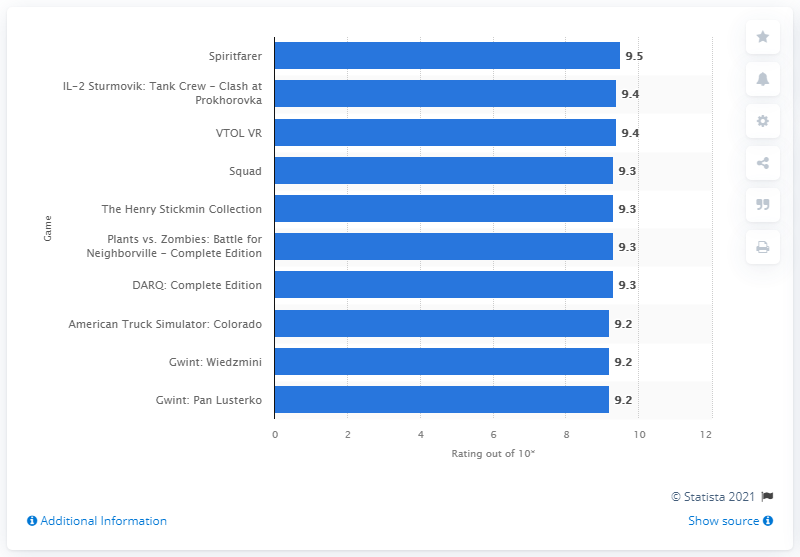Draw attention to some important aspects in this diagram. As of June 2021, the highest rated new video game in Poland was Spiritfarer, which received a high rating from players. The average score of Spiritfarer was 9.5. Squad, along with DARQ: Complete Edition, received a 9.3 rating. 